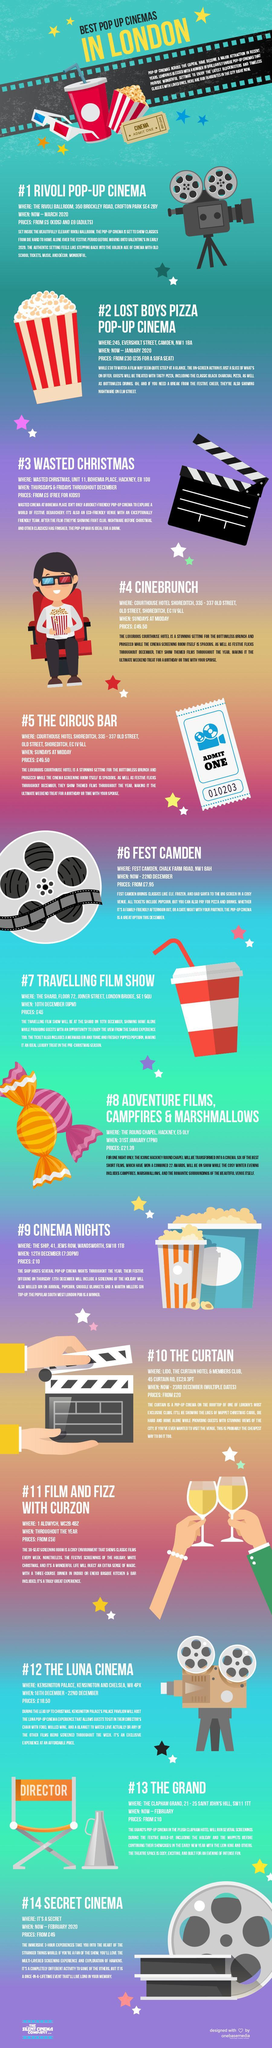Which pop-up has a rate between Wasted Christmas and Rivoli
Answer the question with a short phrase. Fest Camden What is written on the chair beside #13 DIRECTOR Which pop-up provides free entry for kids Wasted Christmas Which pop-up charges only 5 for Children Rivoli Pop-up Cinema What is the number mentioned on the Cinema ticket placed beside the popcorn packet 00012345 Which Pop-up Cinema has the lowest rates Wasted Christmas 